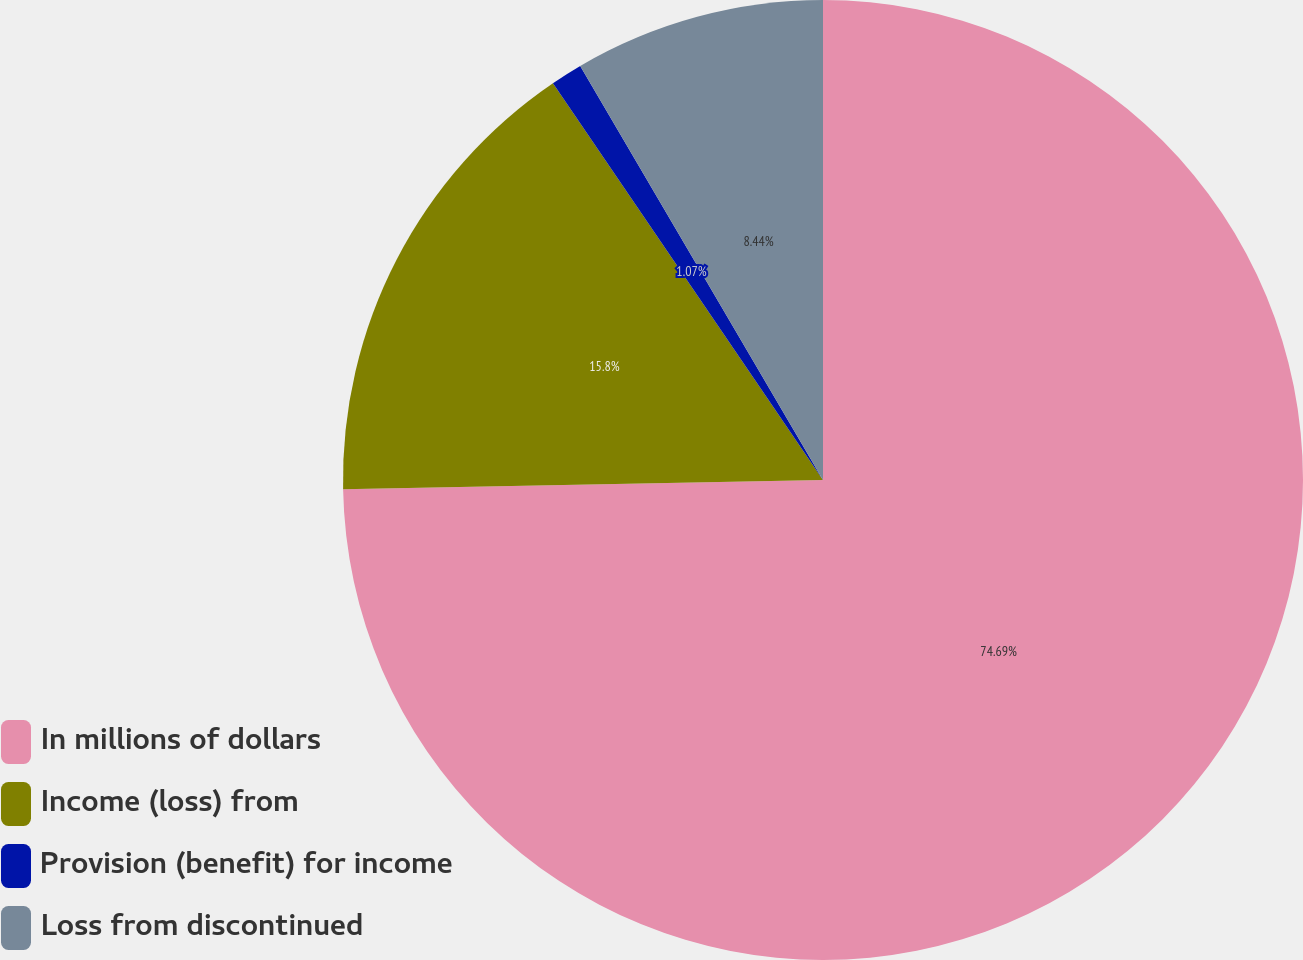Convert chart to OTSL. <chart><loc_0><loc_0><loc_500><loc_500><pie_chart><fcel>In millions of dollars<fcel>Income (loss) from<fcel>Provision (benefit) for income<fcel>Loss from discontinued<nl><fcel>74.69%<fcel>15.8%<fcel>1.07%<fcel>8.44%<nl></chart> 